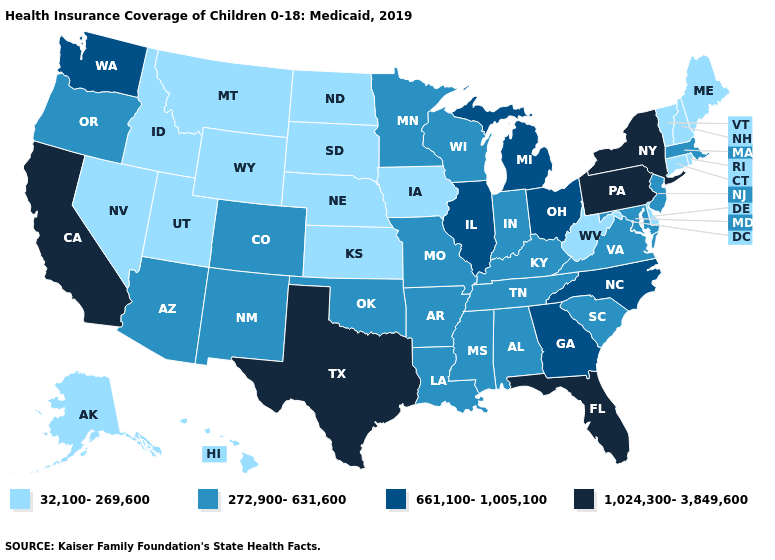Name the states that have a value in the range 1,024,300-3,849,600?
Write a very short answer. California, Florida, New York, Pennsylvania, Texas. What is the value of Maine?
Quick response, please. 32,100-269,600. What is the value of Arizona?
Short answer required. 272,900-631,600. Which states have the highest value in the USA?
Be succinct. California, Florida, New York, Pennsylvania, Texas. Name the states that have a value in the range 1,024,300-3,849,600?
Be succinct. California, Florida, New York, Pennsylvania, Texas. Name the states that have a value in the range 272,900-631,600?
Keep it brief. Alabama, Arizona, Arkansas, Colorado, Indiana, Kentucky, Louisiana, Maryland, Massachusetts, Minnesota, Mississippi, Missouri, New Jersey, New Mexico, Oklahoma, Oregon, South Carolina, Tennessee, Virginia, Wisconsin. Which states have the lowest value in the USA?
Be succinct. Alaska, Connecticut, Delaware, Hawaii, Idaho, Iowa, Kansas, Maine, Montana, Nebraska, Nevada, New Hampshire, North Dakota, Rhode Island, South Dakota, Utah, Vermont, West Virginia, Wyoming. What is the value of West Virginia?
Answer briefly. 32,100-269,600. Name the states that have a value in the range 661,100-1,005,100?
Quick response, please. Georgia, Illinois, Michigan, North Carolina, Ohio, Washington. Does Louisiana have the highest value in the USA?
Quick response, please. No. What is the lowest value in the South?
Give a very brief answer. 32,100-269,600. What is the value of Missouri?
Be succinct. 272,900-631,600. Is the legend a continuous bar?
Be succinct. No. Name the states that have a value in the range 1,024,300-3,849,600?
Give a very brief answer. California, Florida, New York, Pennsylvania, Texas. What is the value of Iowa?
Write a very short answer. 32,100-269,600. 